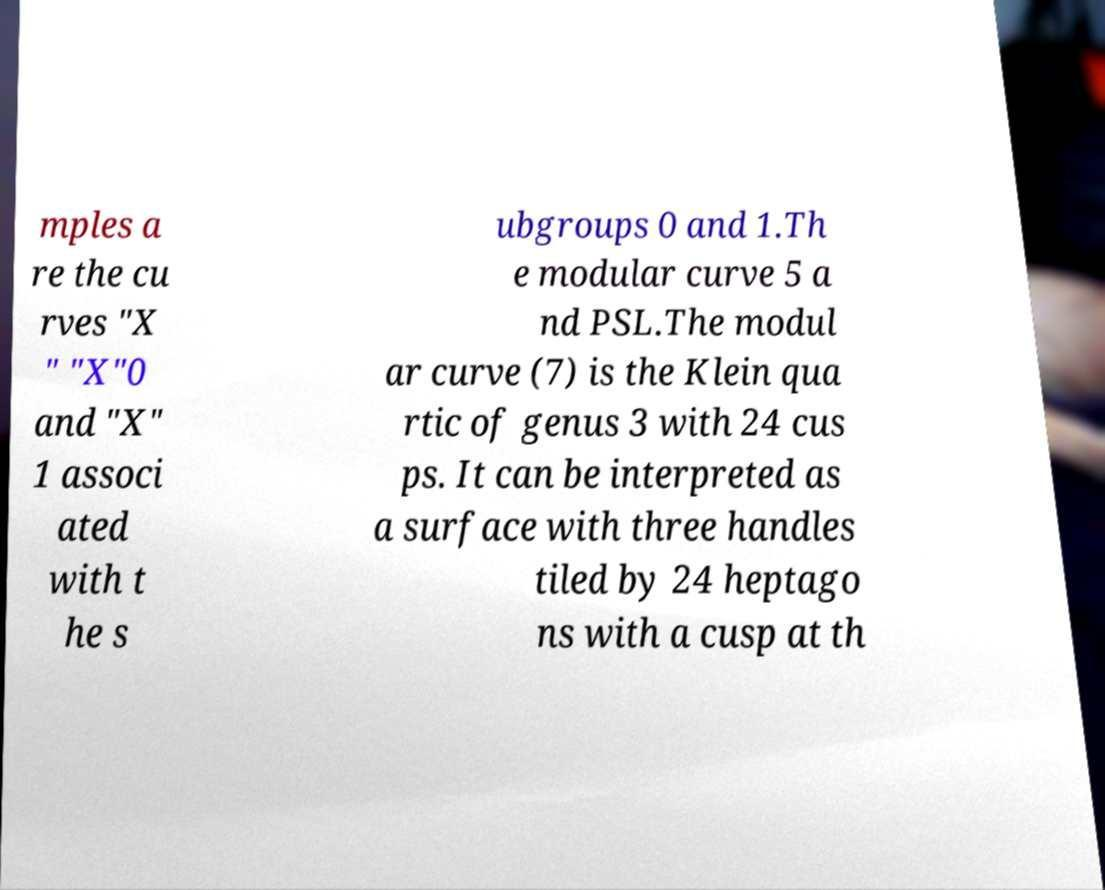Could you extract and type out the text from this image? mples a re the cu rves "X " "X"0 and "X" 1 associ ated with t he s ubgroups 0 and 1.Th e modular curve 5 a nd PSL.The modul ar curve (7) is the Klein qua rtic of genus 3 with 24 cus ps. It can be interpreted as a surface with three handles tiled by 24 heptago ns with a cusp at th 